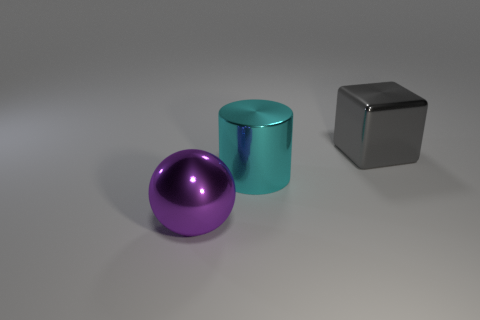There is a shiny block that is the same size as the cyan metal thing; what is its color?
Offer a very short reply. Gray. What shape is the large metal thing that is in front of the cube and right of the large purple metallic sphere?
Provide a short and direct response. Cylinder. What number of metallic objects are the same color as the large sphere?
Your response must be concise. 0. What is the size of the metallic thing that is to the left of the gray block and to the right of the purple metal sphere?
Provide a short and direct response. Large. How many other big objects are the same shape as the purple thing?
Offer a terse response. 0. What is the material of the cyan object?
Your answer should be very brief. Metal. Is the shape of the large gray object the same as the large purple object?
Keep it short and to the point. No. Is there a small red cylinder that has the same material as the big gray object?
Your answer should be compact. No. There is a metal object that is both behind the purple metallic ball and in front of the cube; what is its color?
Your response must be concise. Cyan. What is the material of the big thing that is behind the cyan thing?
Provide a succinct answer. Metal. 